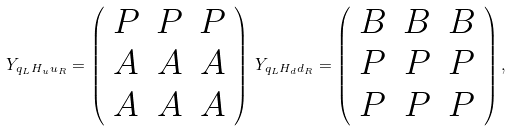Convert formula to latex. <formula><loc_0><loc_0><loc_500><loc_500>Y _ { q _ { L } H _ { u } u _ { R } } = \left ( \begin{array} { c c c } P & P & P \\ A & A & A \\ A & A & A \end{array} \right ) \, Y _ { q _ { L } H _ { d } d _ { R } } = \left ( \begin{array} { c c c } B & B & B \\ P & P & P \\ P & P & P \end{array} \right ) ,</formula> 